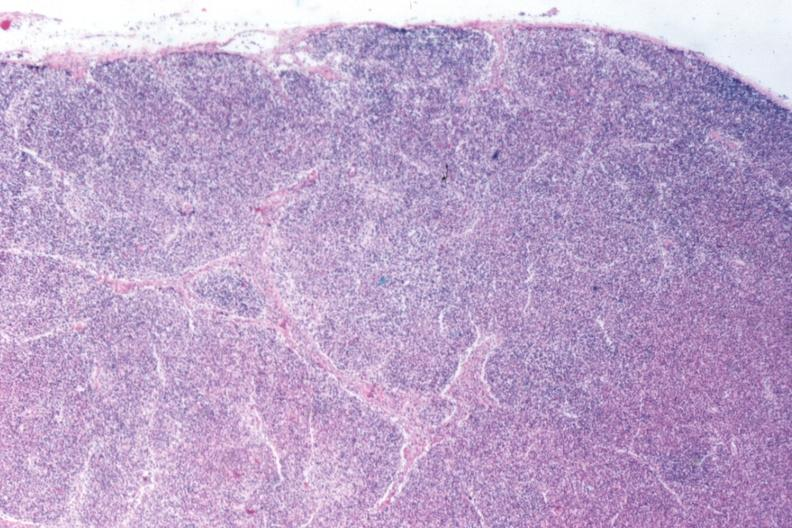what is present?
Answer the question using a single word or phrase. Lymph node 